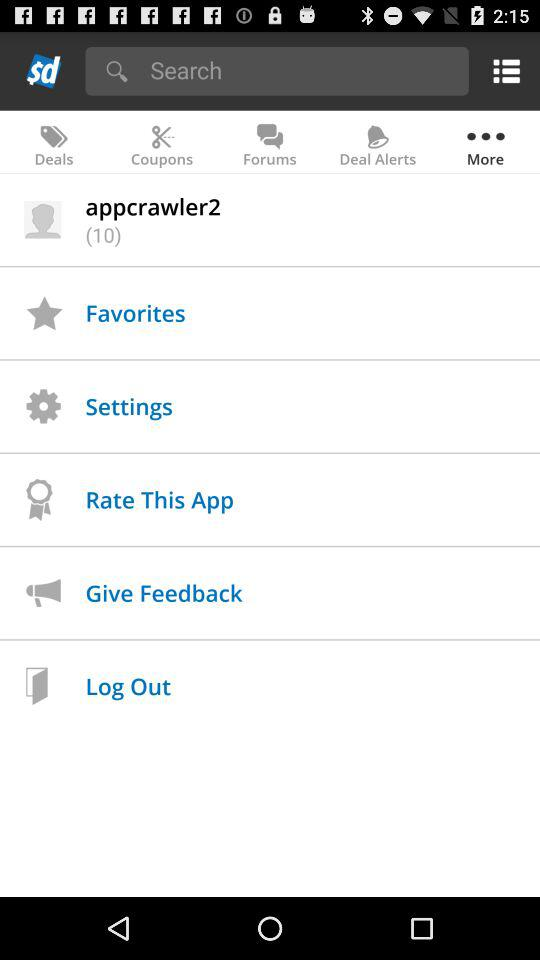Which tab has been selected? The selected tab is "More". 